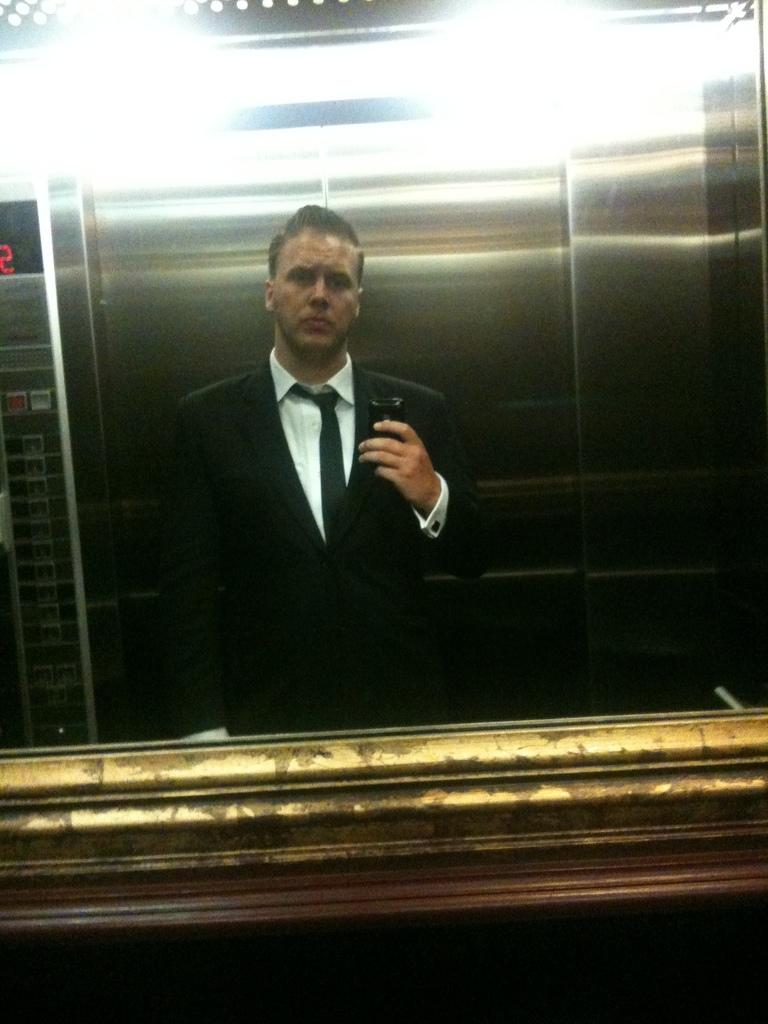What is located in the foreground of the image? There is a mirror in the foreground of the image. What does the mirror reflect in the image? The mirror reflects a person holding a camera. Where was the image taken? The image was taken inside a lift. What type of print can be seen on the wall behind the person holding the camera? There is no print visible on the wall behind the person holding the camera in the image. 